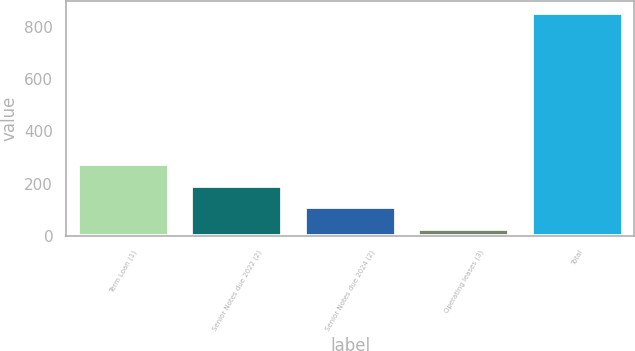Convert chart. <chart><loc_0><loc_0><loc_500><loc_500><bar_chart><fcel>Term Loan (1)<fcel>Senior Notes due 2022 (2)<fcel>Senior Notes due 2024 (2)<fcel>Operating leases (3)<fcel>Total<nl><fcel>275.01<fcel>192.14<fcel>109.27<fcel>26.4<fcel>855.1<nl></chart> 